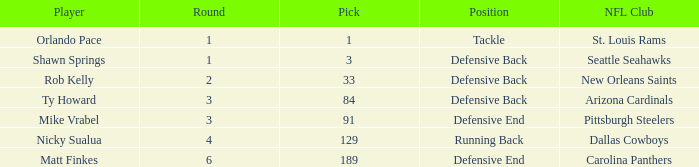What round features a selection below 189, involving arizona cardinals as the nfl team? 3.0. 